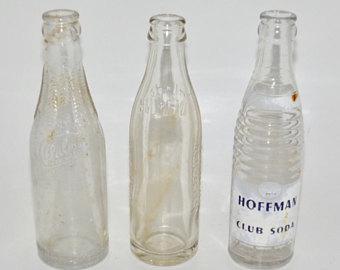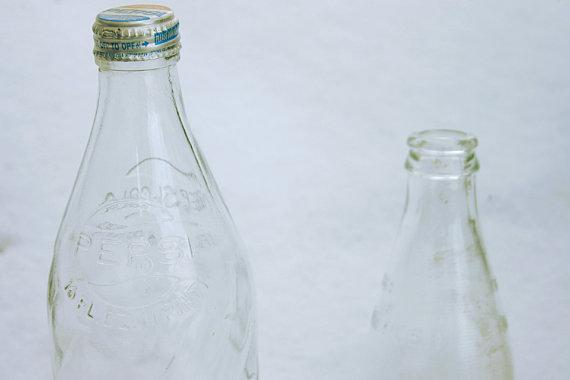The first image is the image on the left, the second image is the image on the right. Assess this claim about the two images: "In one image all the bottles are made of plastic.". Correct or not? Answer yes or no. No. The first image is the image on the left, the second image is the image on the right. Examine the images to the left and right. Is the description "There are exactly six bottles." accurate? Answer yes or no. No. 